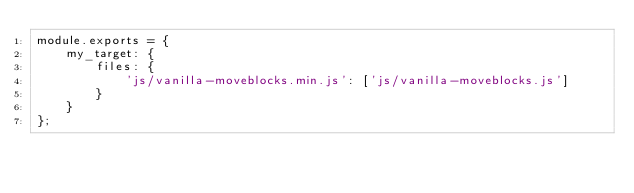Convert code to text. <code><loc_0><loc_0><loc_500><loc_500><_JavaScript_>module.exports = {
    my_target: {
        files: {
            'js/vanilla-moveblocks.min.js': ['js/vanilla-moveblocks.js']
        }
    }
};
</code> 